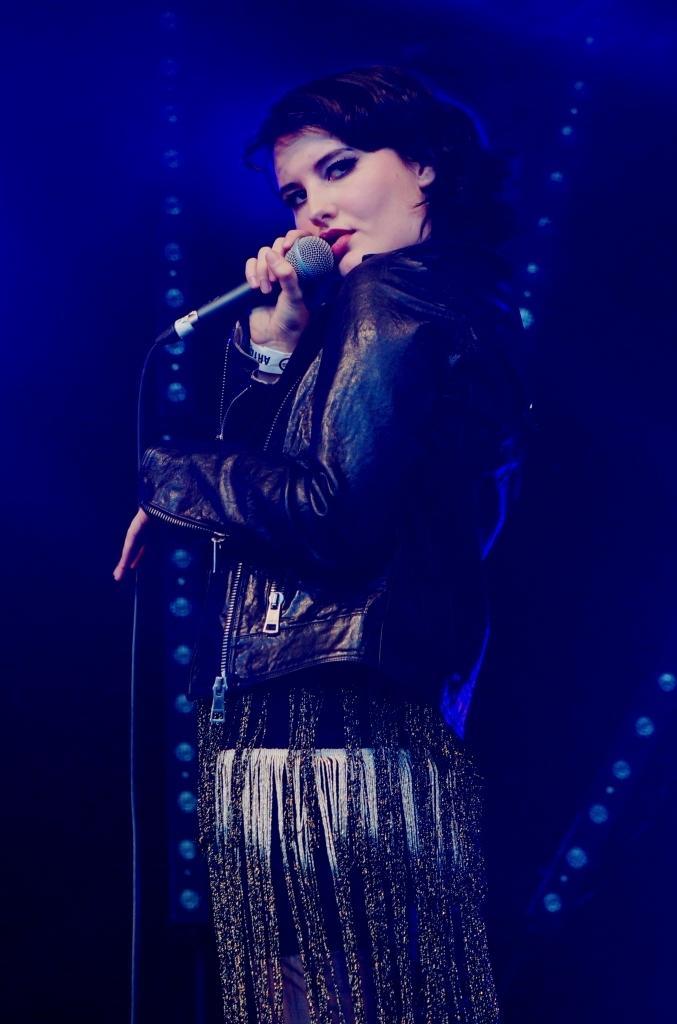In one or two sentences, can you explain what this image depicts? She is standing and she is holding a mic. 